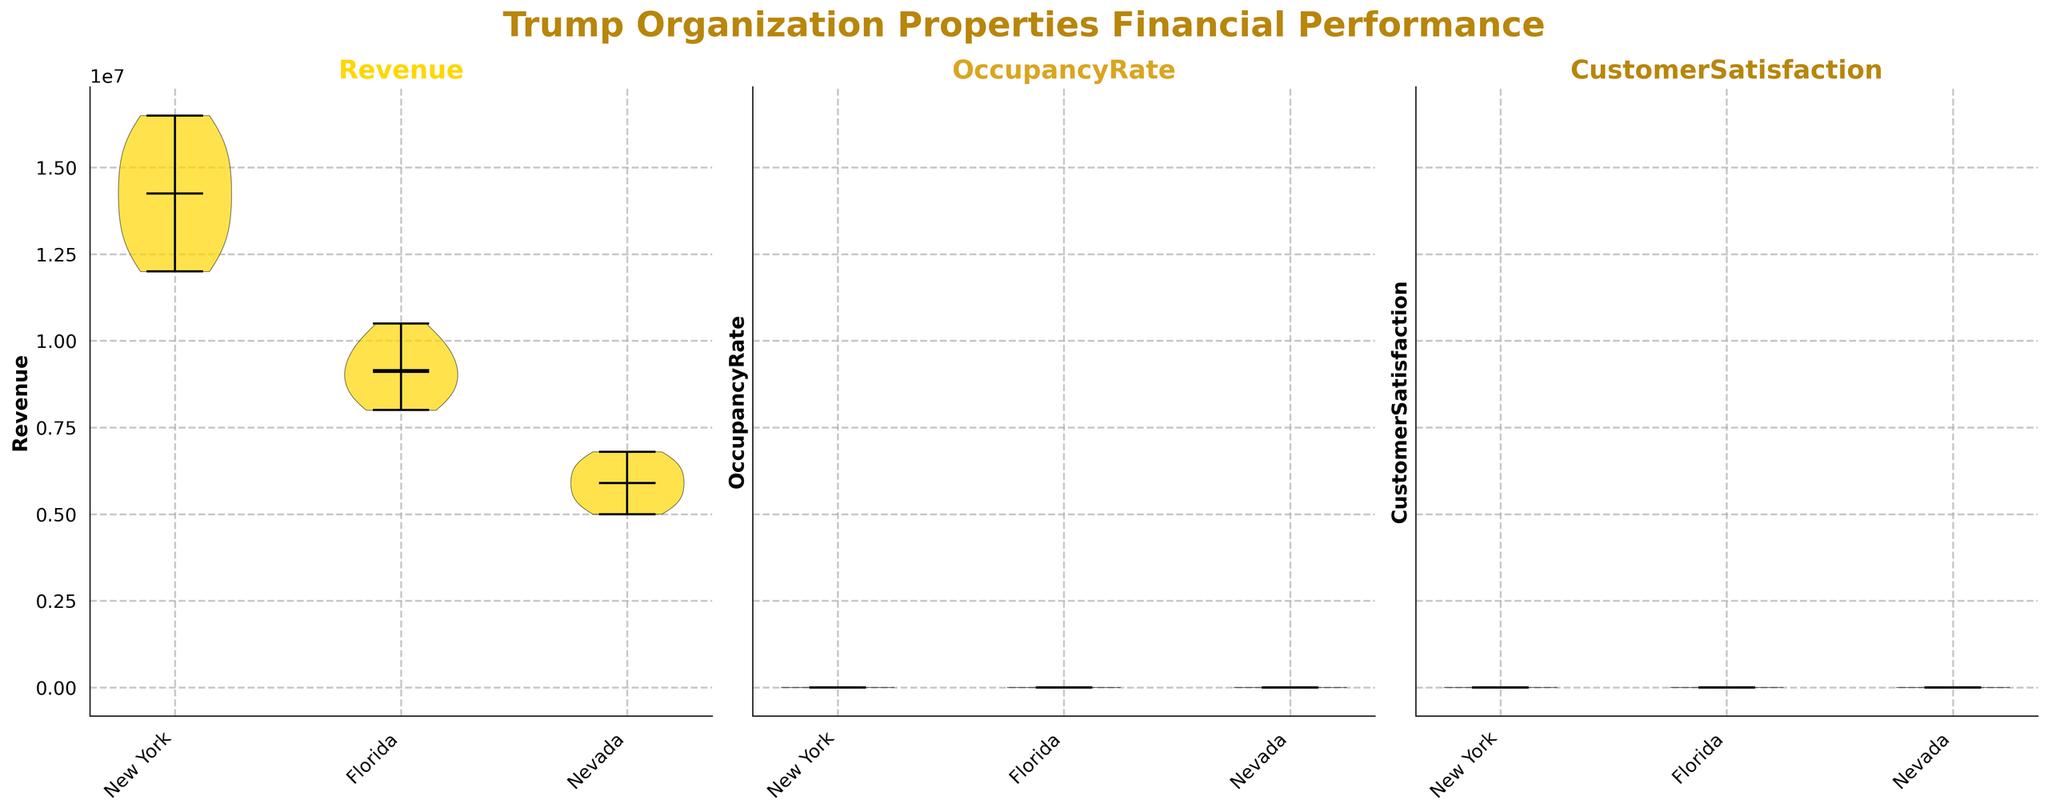What is the title of the figure? The title is found at the top of the figure and describes the overall content of the plot, helping to understand what the chart is about.
Answer: Trump Organization Properties Financial Performance What metrics are displayed in the subplots? The metrics are indicated in the title of each subplot, showing which financial performance measures are being visualized.
Answer: Revenue, OccupancyRate, CustomerSatisfaction How many regions are compared in the figure? The number of unique tick labels on the x-axis under each subplot indicates the number of regions compared.
Answer: 3 Which region has the highest average revenue according to the figure? To determine this, visually inspect the Revenue subplot and compare the positions of the means (indicated by markers) of the violins representing different regions.
Answer: New York Is the customer satisfaction generally higher in New York or Florida? Compare the medians of the violins in the CustomerSatisfaction subplot for New York and Florida. The violin with the higher median marker indicates higher customer satisfaction.
Answer: New York Which metric shows the smallest variance across regions? Visual inspection of the width and spread of the violins in each subplot; the metric with the least spread across regions shows the smallest variance.
Answer: CustomerSatisfaction Do any regions show a noticeable dip in occupancy rates during the timeframe? Look for any violin plots in the OccupancyRate subplot that show a lower density region around a specific value range indicating a dip.
Answer: Yes, Nevada around 2020 Which region has the greatest fluctuation in revenue over the decade? Compare the widths of the violins in the Revenue subplot. The region with the widest violin indicates the greatest fluctuation.
Answer: New York How do the customer satisfaction ratings compare between Florida and Nevada? Compare the medians and the spread of the violins in the CustomerSatisfaction subplot for Florida and Nevada. Assess the central tendency and variability.
Answer: Florida generally has higher customer satisfaction Are the occupancy rates consistent across regions? Observe the spread and central tendency of the violins in the OccupancyRate subplot. Consistency is indicated by similar medians and narrow spreads.
Answer: No, they vary across regions 